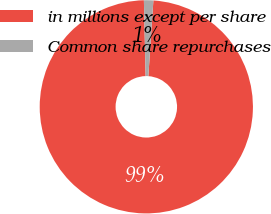Convert chart. <chart><loc_0><loc_0><loc_500><loc_500><pie_chart><fcel>in millions except per share<fcel>Common share repurchases<nl><fcel>98.58%<fcel>1.42%<nl></chart> 